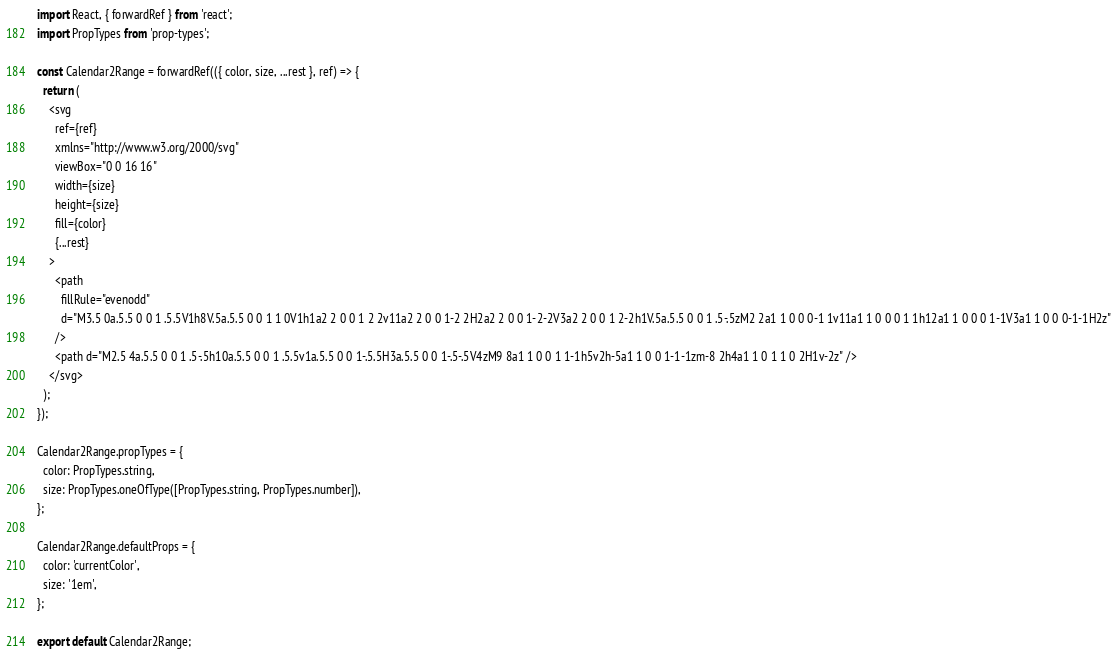<code> <loc_0><loc_0><loc_500><loc_500><_JavaScript_>import React, { forwardRef } from 'react';
import PropTypes from 'prop-types';

const Calendar2Range = forwardRef(({ color, size, ...rest }, ref) => {
  return (
    <svg
      ref={ref}
      xmlns="http://www.w3.org/2000/svg"
      viewBox="0 0 16 16"
      width={size}
      height={size}
      fill={color}
      {...rest}
    >
      <path
        fillRule="evenodd"
        d="M3.5 0a.5.5 0 0 1 .5.5V1h8V.5a.5.5 0 0 1 1 0V1h1a2 2 0 0 1 2 2v11a2 2 0 0 1-2 2H2a2 2 0 0 1-2-2V3a2 2 0 0 1 2-2h1V.5a.5.5 0 0 1 .5-.5zM2 2a1 1 0 0 0-1 1v11a1 1 0 0 0 1 1h12a1 1 0 0 0 1-1V3a1 1 0 0 0-1-1H2z"
      />
      <path d="M2.5 4a.5.5 0 0 1 .5-.5h10a.5.5 0 0 1 .5.5v1a.5.5 0 0 1-.5.5H3a.5.5 0 0 1-.5-.5V4zM9 8a1 1 0 0 1 1-1h5v2h-5a1 1 0 0 1-1-1zm-8 2h4a1 1 0 1 1 0 2H1v-2z" />
    </svg>
  );
});

Calendar2Range.propTypes = {
  color: PropTypes.string,
  size: PropTypes.oneOfType([PropTypes.string, PropTypes.number]),
};

Calendar2Range.defaultProps = {
  color: 'currentColor',
  size: '1em',
};

export default Calendar2Range;
</code> 